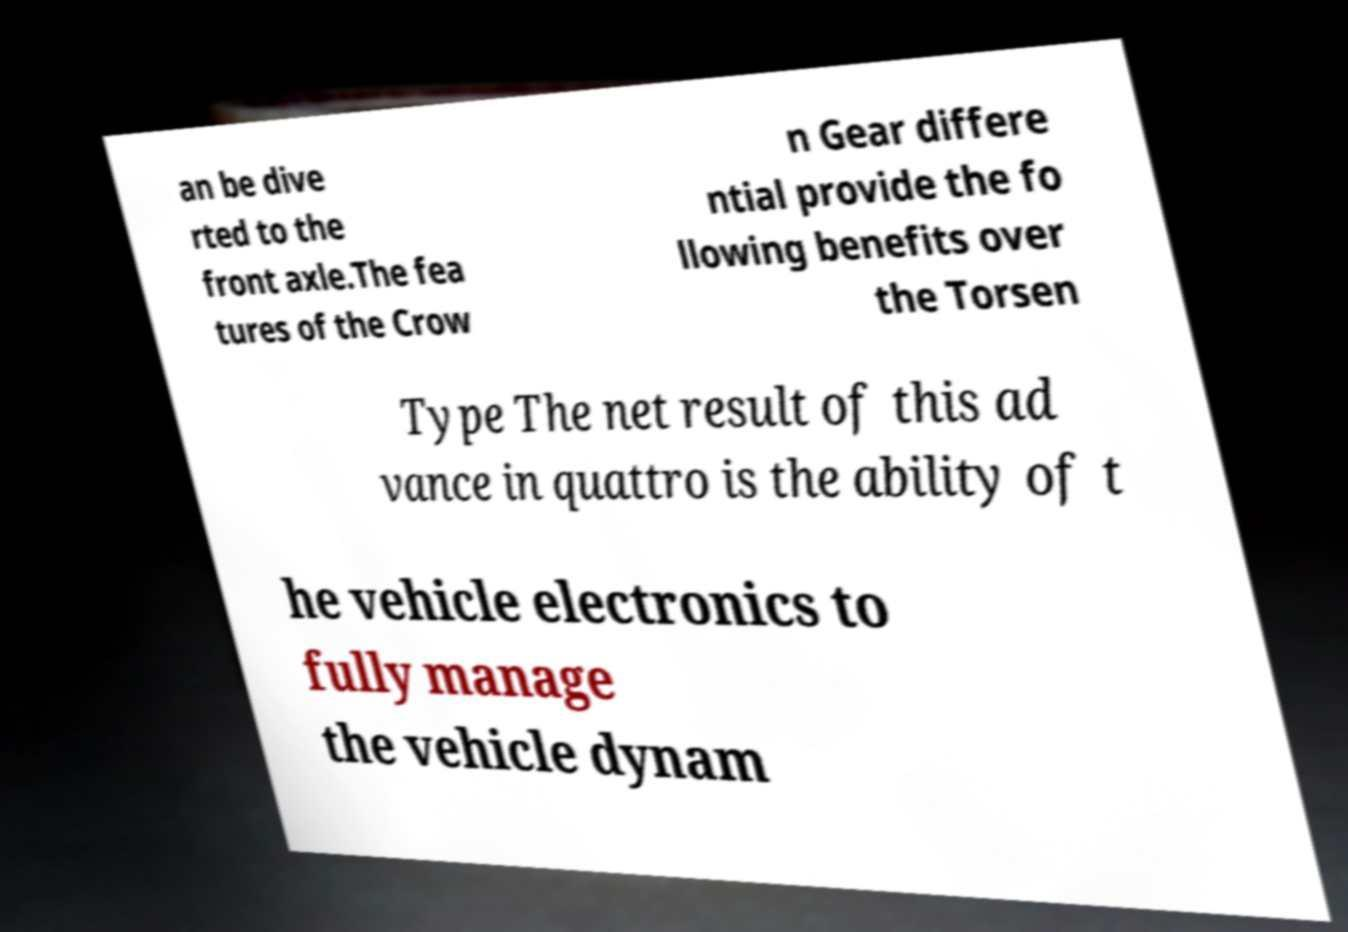Please identify and transcribe the text found in this image. an be dive rted to the front axle.The fea tures of the Crow n Gear differe ntial provide the fo llowing benefits over the Torsen Type The net result of this ad vance in quattro is the ability of t he vehicle electronics to fully manage the vehicle dynam 